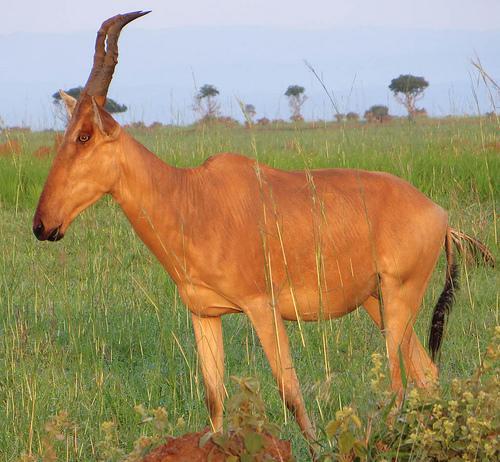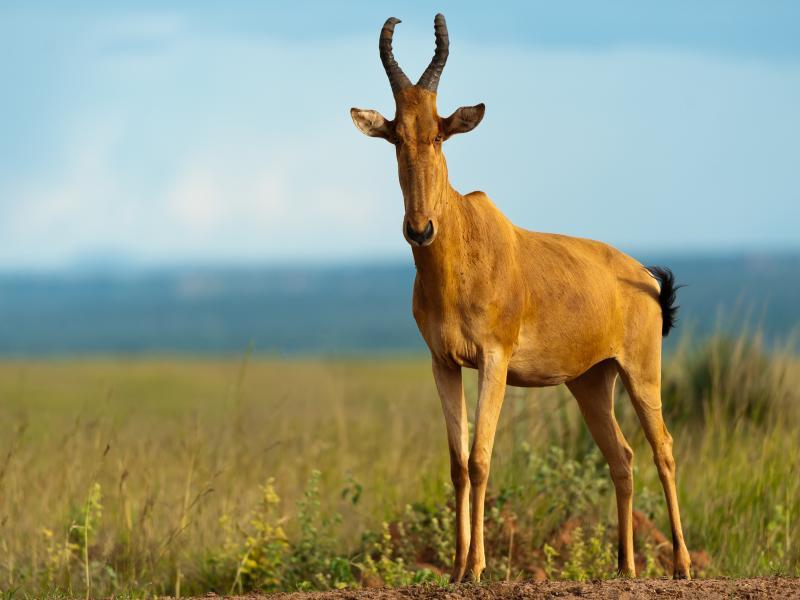The first image is the image on the left, the second image is the image on the right. Considering the images on both sides, is "There is exactly one animal in the image on the right." valid? Answer yes or no. Yes. 